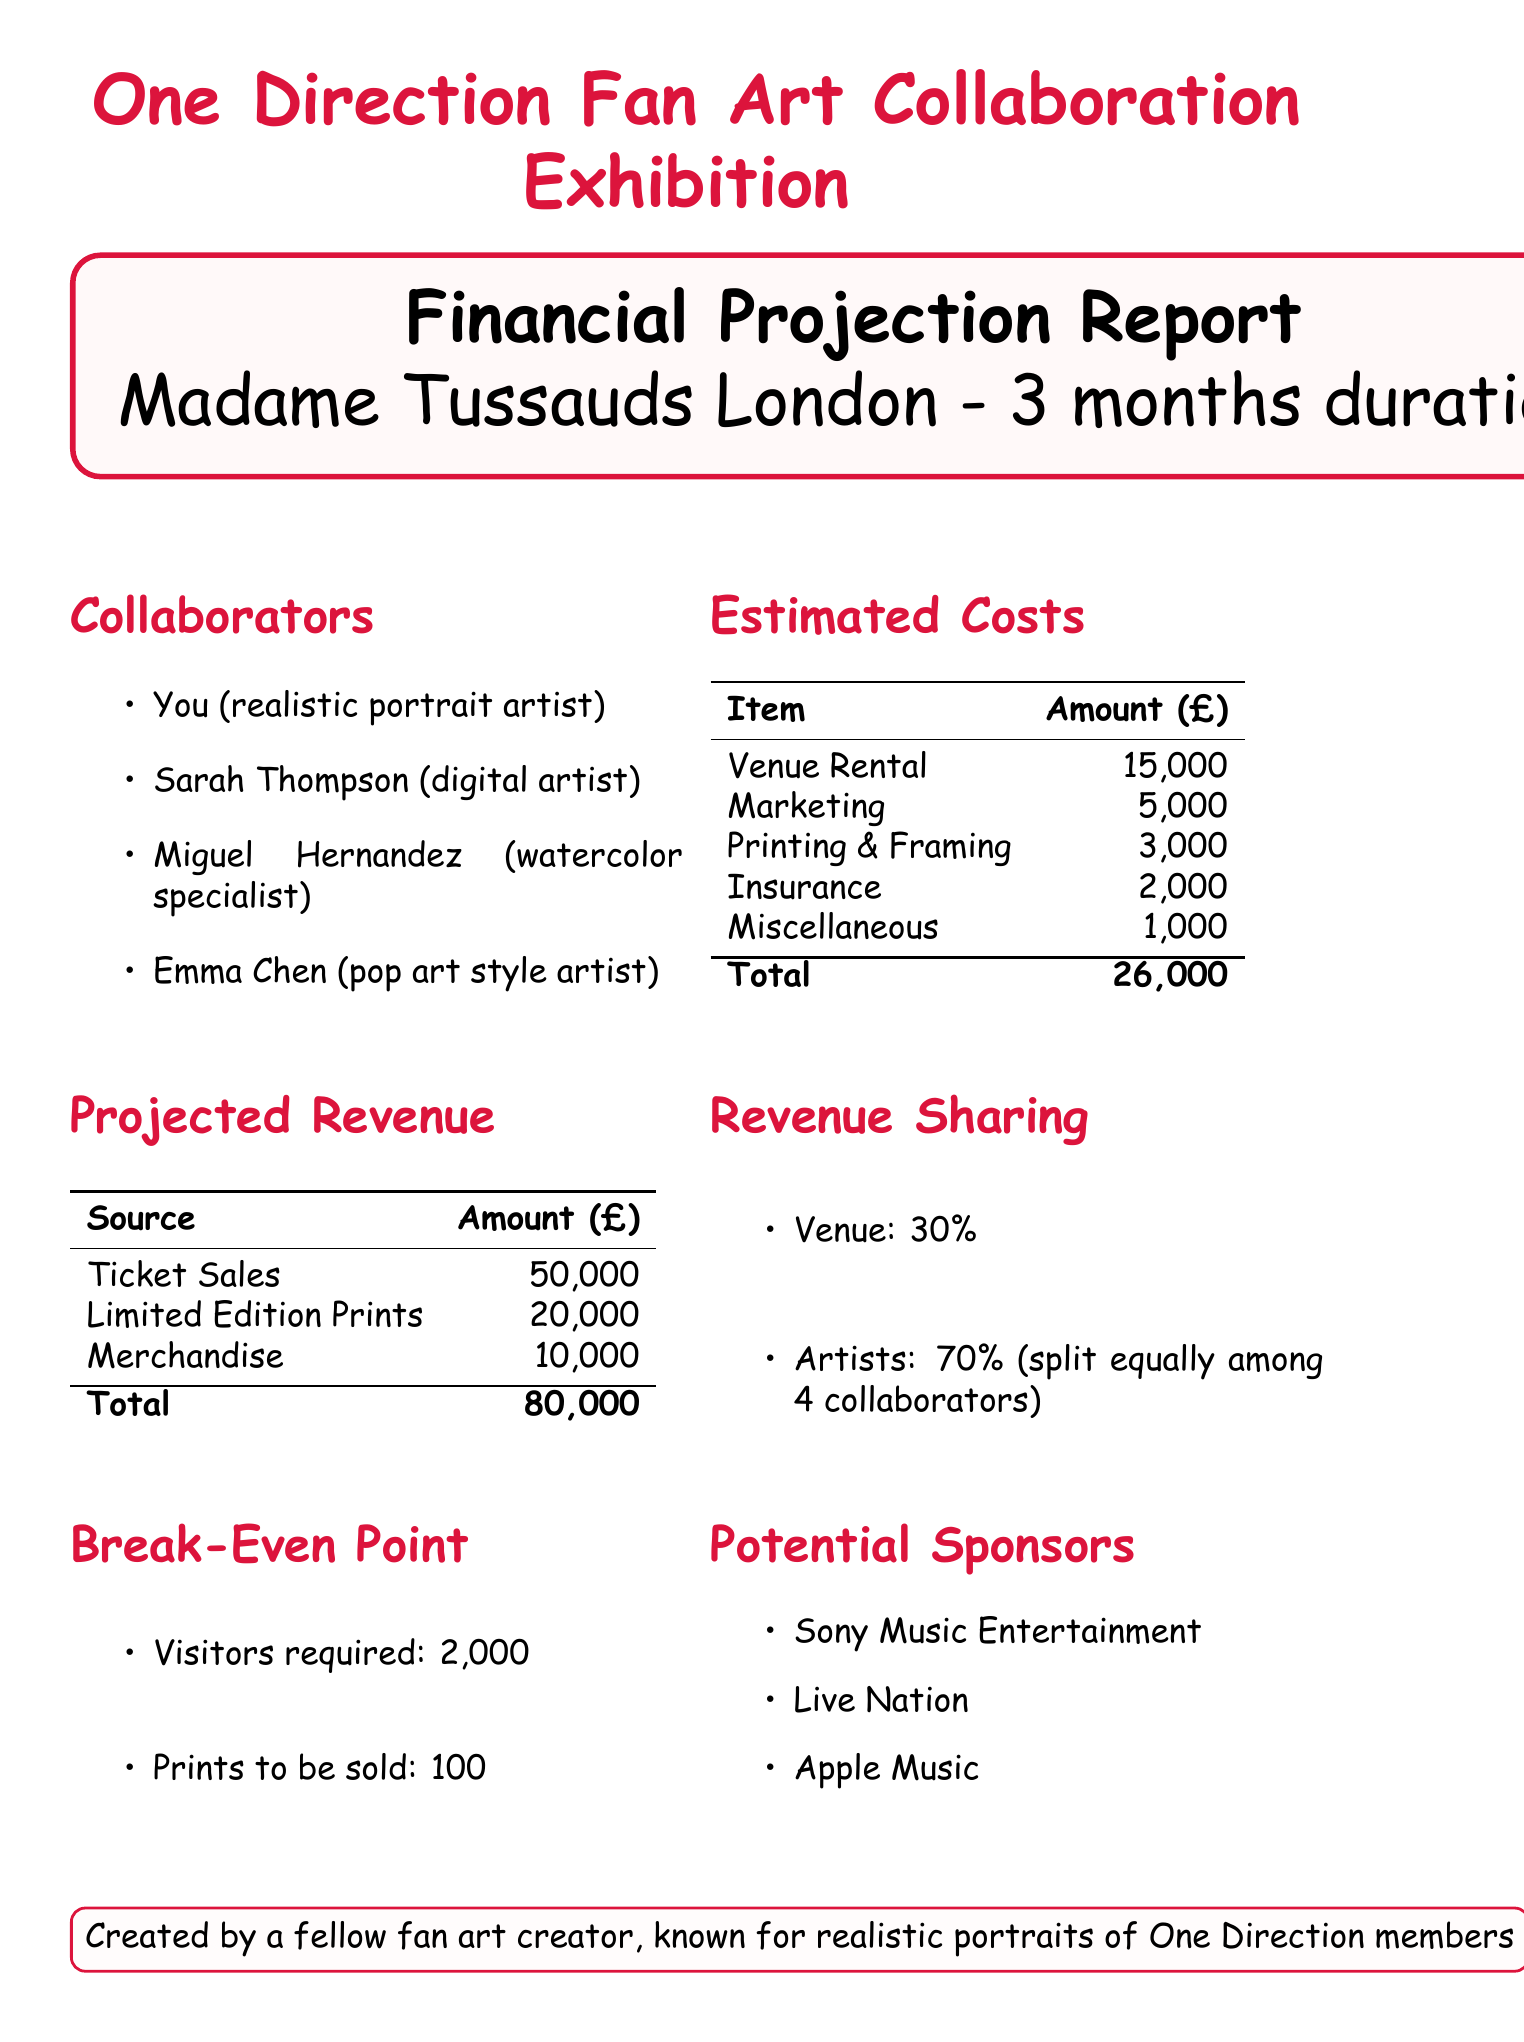What is the project title? The project title is listed at the top of the document, explicitly stating the focus of the report.
Answer: One Direction Fan Art Collaboration Exhibition How many collaborators are involved? The number of collaborators is indicated by the list of names under the Collaborators section.
Answer: 4 What is the estimated cost for printing and framing? The document specifies each cost item, including the amount for printing and framing.
Answer: 3000 What percentage of revenue goes to the venue? The revenue sharing arrangement details the split between the venue and the artists.
Answer: 30% What is the total projected revenue? The total projected revenue is the sum of all revenue sources provided in the document.
Answer: 80000 How many visitors are required to break even? The break-even point section provides the necessary visitor count for the project.
Answer: 2000 What is the venue for the exhibition? The venue is explicitly stated within the context of the project details.
Answer: Madame Tussauds London Who is the watercolor specialist collaborator? The specific collaborator who specializes in watercolor is listed under collaborators.
Answer: Miguel Hernandez What is the duration of the exhibition? The exhibition duration is clearly mentioned in the introductory details of the document.
Answer: 3 months 